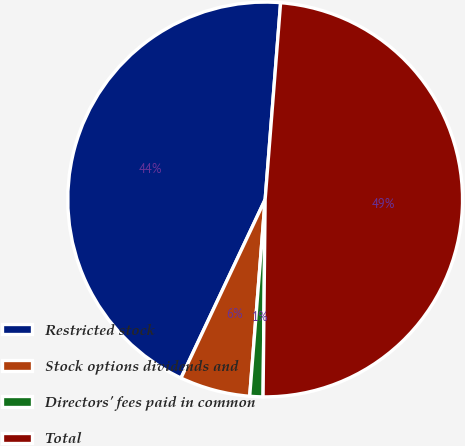Convert chart. <chart><loc_0><loc_0><loc_500><loc_500><pie_chart><fcel>Restricted stock<fcel>Stock options dividends and<fcel>Directors' fees paid in common<fcel>Total<nl><fcel>44.24%<fcel>5.76%<fcel>1.08%<fcel>48.92%<nl></chart> 